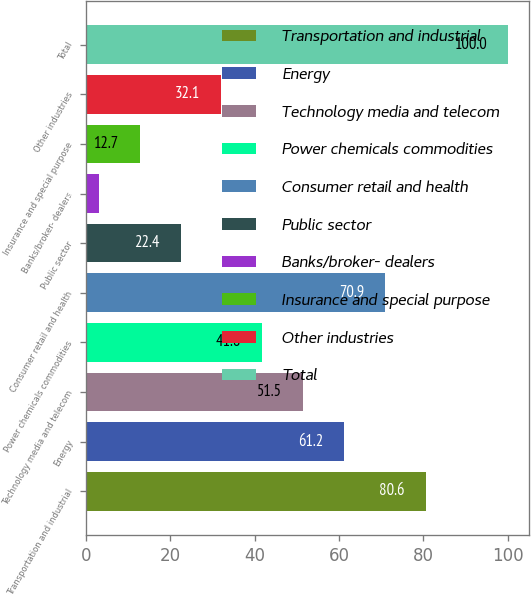<chart> <loc_0><loc_0><loc_500><loc_500><bar_chart><fcel>Transportation and industrial<fcel>Energy<fcel>Technology media and telecom<fcel>Power chemicals commodities<fcel>Consumer retail and health<fcel>Public sector<fcel>Banks/broker- dealers<fcel>Insurance and special purpose<fcel>Other industries<fcel>Total<nl><fcel>80.6<fcel>61.2<fcel>51.5<fcel>41.8<fcel>70.9<fcel>22.4<fcel>3<fcel>12.7<fcel>32.1<fcel>100<nl></chart> 